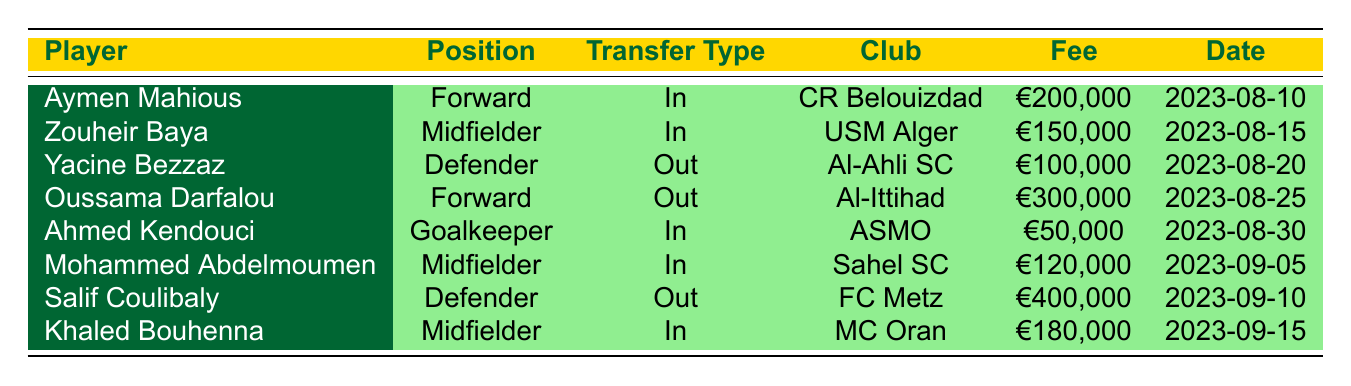What is the transfer fee for Aymen Mahious? The table shows the transfer fee for Aymen Mahious under the "Fee" column. It is listed as €200,000.
Answer: €200,000 How many players were transferred in? The table lists three players with the transfer type "In": Aymen Mahious, Zouheir Baya, and Ahmed Kendouci. Counting these, the total is 4 players transferred in.
Answer: 4 Which player was transferred out for the highest fee? To find this, we look at the "Out" transfer types: Yacine Bezzaz (€100,000), Oussama Darfalou (€300,000), and Salif Coulibaly (€400,000). The highest fee is €400,000 for Salif Coulibaly.
Answer: Salif Coulibaly Did ES Sétif acquire any players from clubs outside of Algeria? All players listed in the "In" transfers come from clubs in Algeria: CR Belouizdad, USM Alger, ASMO, and MC Oran. Therefore, the answer is no.
Answer: No What is the total transfer fee spent on incoming players? The incoming transfer fees are: €200,000 (Mahious) + €150,000 (Baya) + €50,000 (Kendouci) + €120,000 (Abdelmoumen) + €180,000 (Bouhenna) = €700,000. Thus, the total fee is €700,000.
Answer: €700,000 Which midfielder was signed from USM Alger? Referencing the "In" transfers, Zouheir Baya is the midfielder listed who came from USM Alger.
Answer: Zouheir Baya What are the positions of all players transferred out? Reviewing the "Out" transfers: Yacine Bezzaz (Defender), Oussama Darfalou (Forward), and Salif Coulibaly (Defender). The positions are Defender, Forward, and Defender.
Answer: Defender, Forward, Defender How many players were transferred to clubs outside of Algeria? The table shows two players transferred out: Yacine Bezzaz (to Al-Ahli SC) and Oussama Darfalou (to Al-Ittihad), both of which are clubs outside of Algeria. Therefore, the answer is 2.
Answer: 2 Did ES Sétif receive a transfer fee for all outgoing players? Yes, all outgoing players are associated with specific transfer fees: Yacine Bezzaz (€100,000), Oussama Darfalou (€300,000), Salif Coulibaly (€400,000). Thus, the answer is yes.
Answer: Yes 